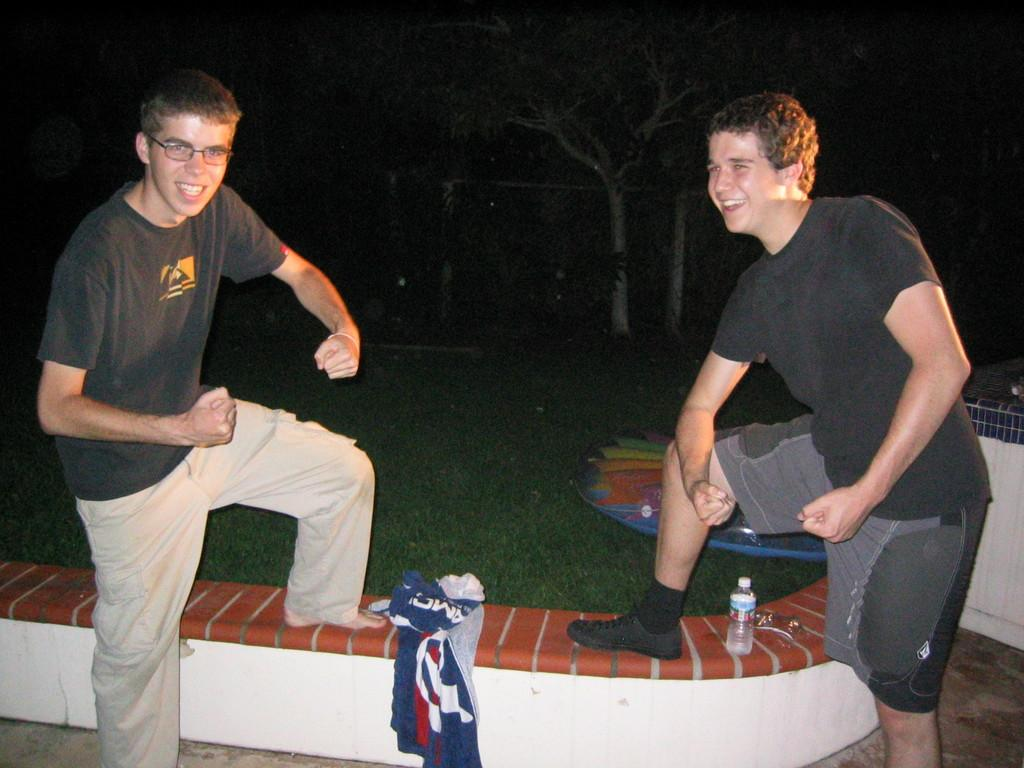What is the overall lighting condition in the image? The image is dark. What are the two people in the image doing? The two people are bending and posing for the picture. What can be seen on the divider in the image? There are objects on a divider in the image. What type of natural environment is visible in the image? There is grass and trees visible in the image. How many chairs are visible in the image? There are no chairs visible in the image. What type of rice is being cooked in the image? There is no rice present in the image. 